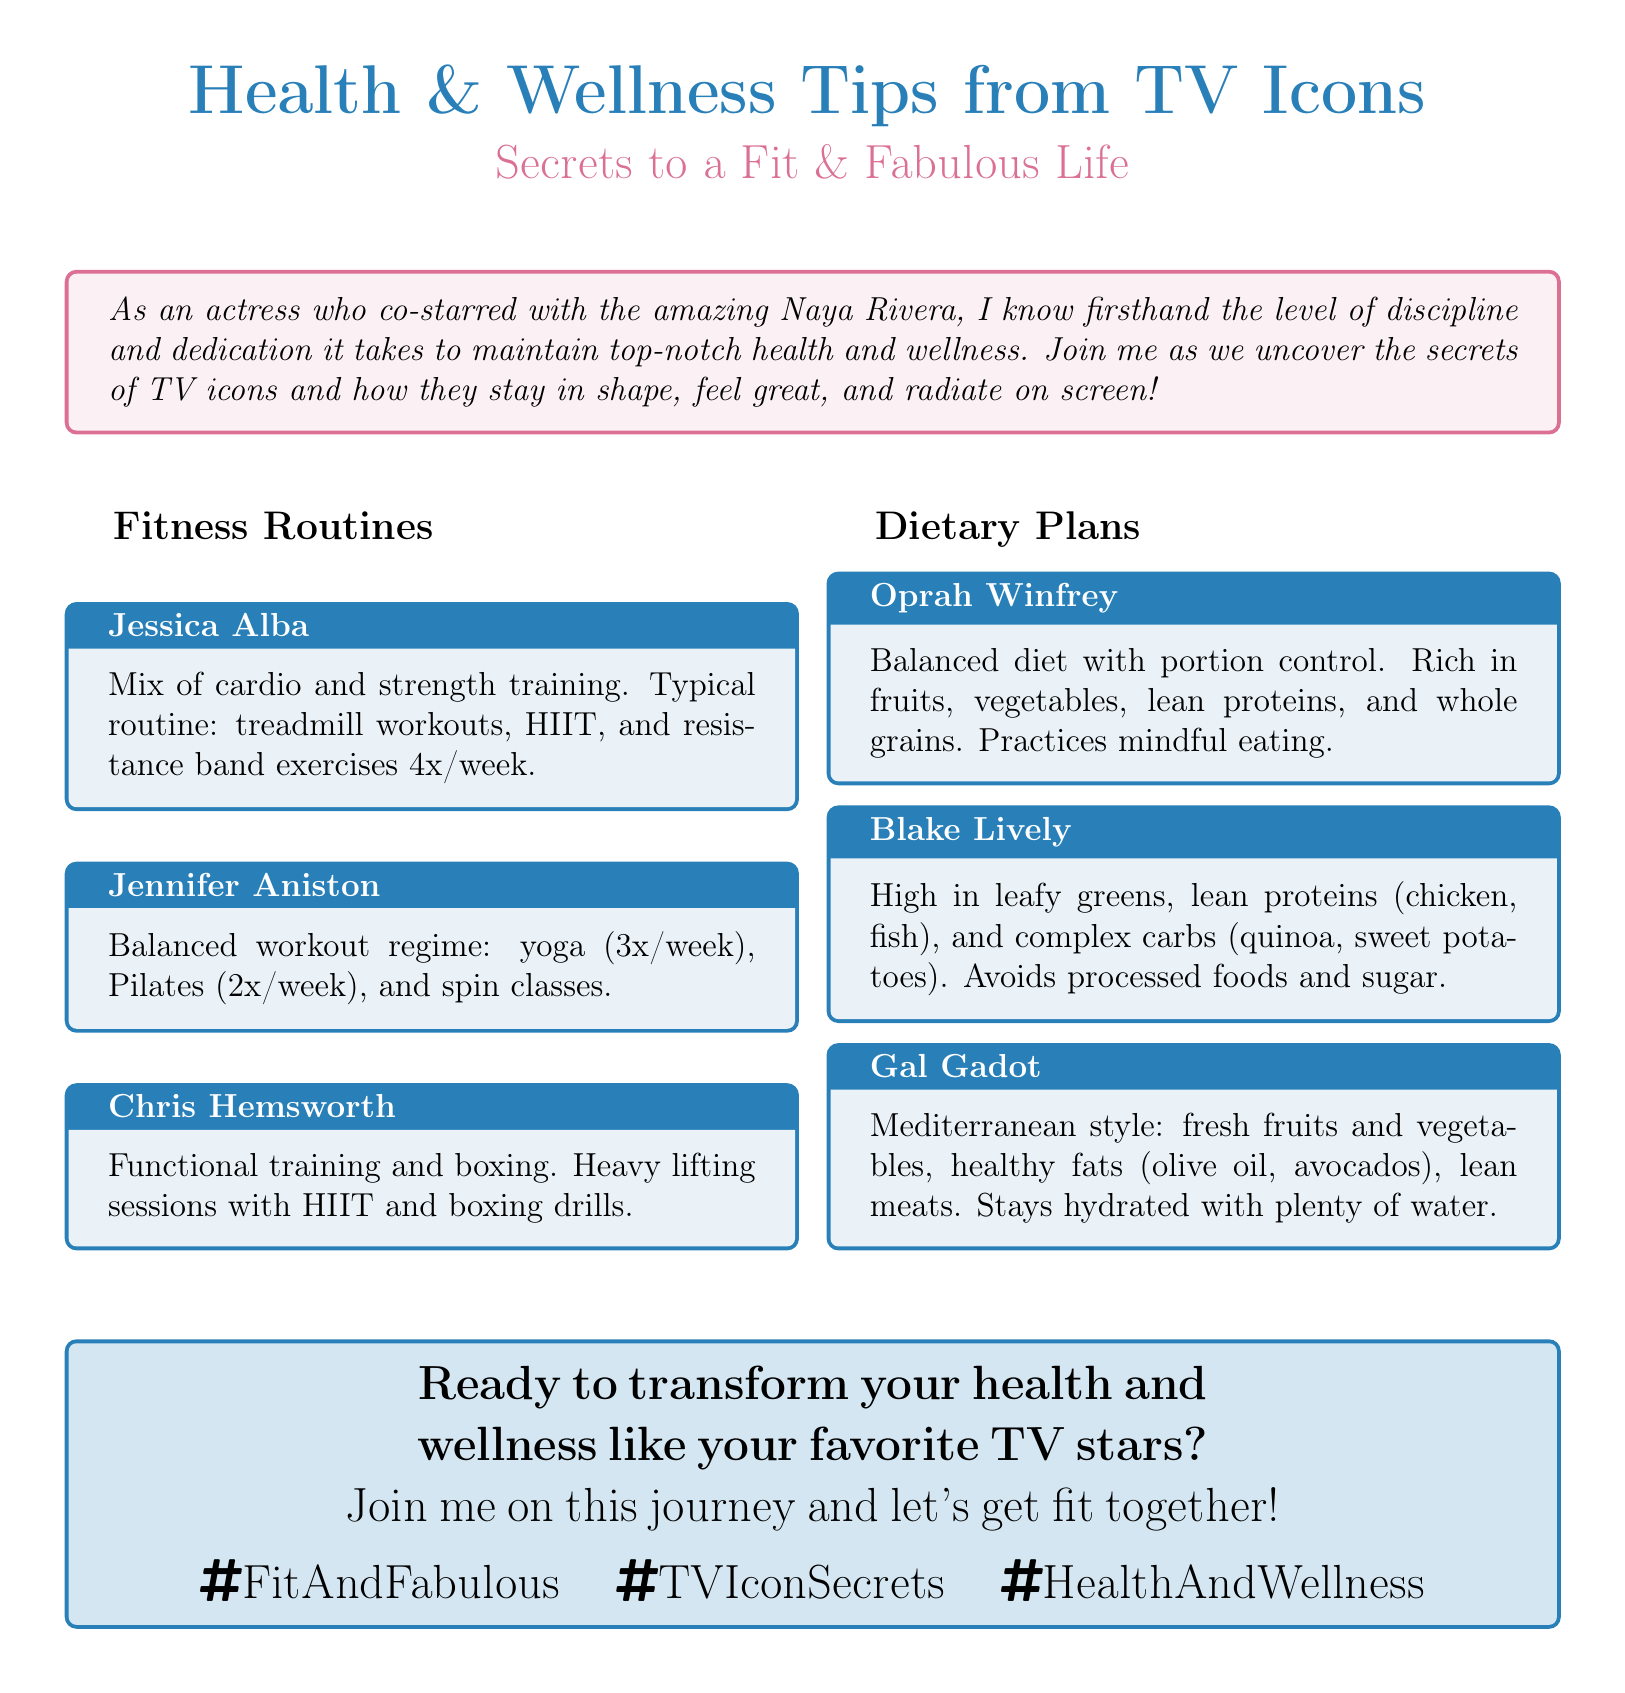What is the title of the document? The title of the document is presented in a prominent format at the beginning, stating "Health & Wellness Tips from TV Icons".
Answer: Health & Wellness Tips from TV Icons Who follows a Mediterranean dietary style? The document lists Gal Gadot's dietary plan, which is described as Mediterranean style.
Answer: Gal Gadot How many times a week does Jennifer Aniston practice yoga? The document specifies that Jennifer Aniston incorporates yoga into her routine three times a week.
Answer: 3 What type of training does Chris Hemsworth focus on? The document states that Chris Hemsworth's training includes functional training and boxing.
Answer: Functional training and boxing What is a common dietary habit mentioned by Oprah Winfrey? The document notes that Oprah Winfrey practices mindful eating as part of her balanced diet.
Answer: Mindful eating How many fitness routines are listed in the document? The document provides a total of six distinct fitness routines from various celebrities.
Answer: 6 What is the color code for the document's background? The background color is specified as white in the document.
Answer: White What is the hashtag mentioned for the health and wellness theme? The document includes a hashtag related to health and wellness, "FitAndFabulous".
Answer: FitAndFabulous Which celebrity emphasizes avoiding processed foods? Blake Lively's dietary plan highlights avoiding processed foods and sugar.
Answer: Blake Lively 